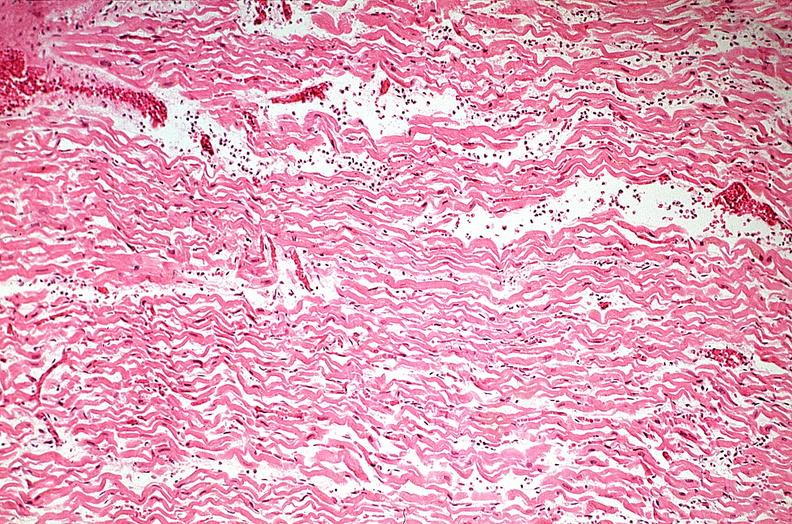what does this image show?
Answer the question using a single word or phrase. Heart 